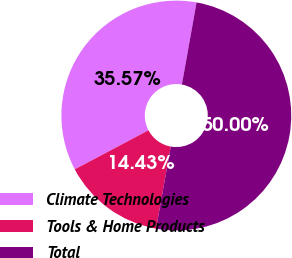<chart> <loc_0><loc_0><loc_500><loc_500><pie_chart><fcel>Climate Technologies<fcel>Tools & Home Products<fcel>Total<nl><fcel>35.57%<fcel>14.43%<fcel>50.0%<nl></chart> 